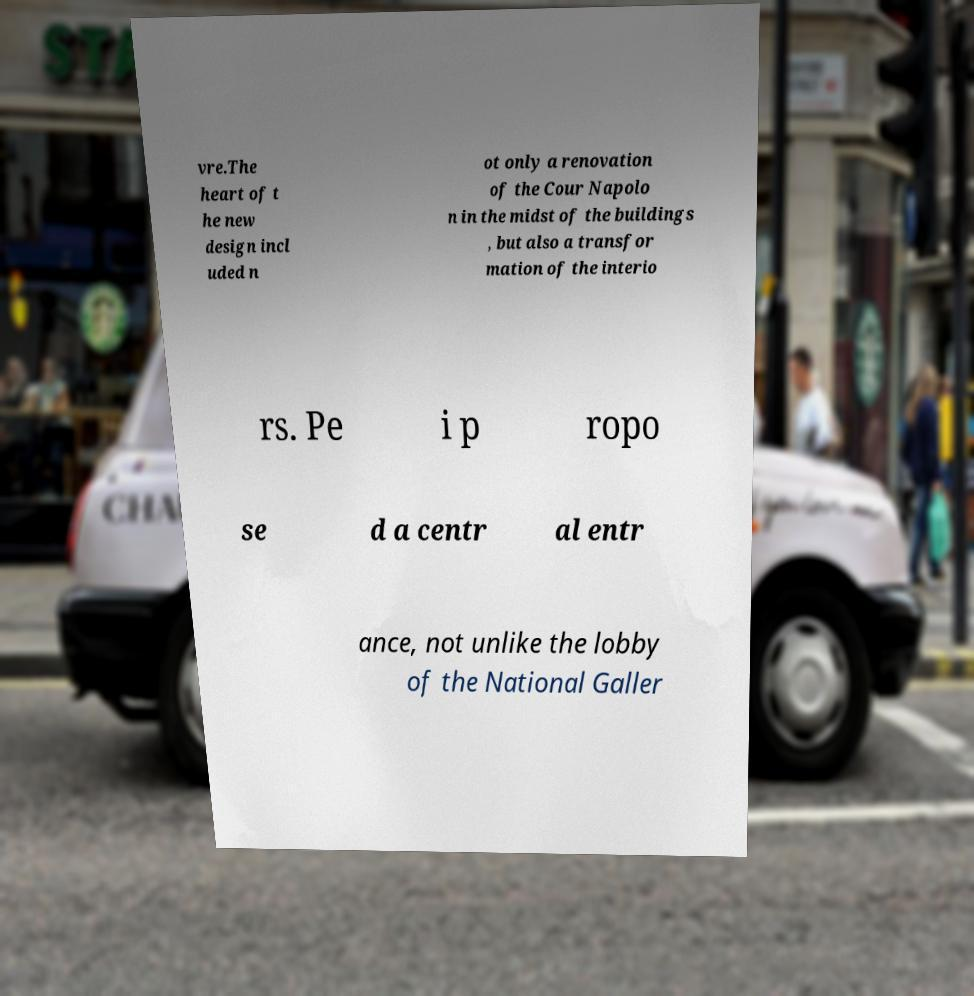For documentation purposes, I need the text within this image transcribed. Could you provide that? vre.The heart of t he new design incl uded n ot only a renovation of the Cour Napolo n in the midst of the buildings , but also a transfor mation of the interio rs. Pe i p ropo se d a centr al entr ance, not unlike the lobby of the National Galler 